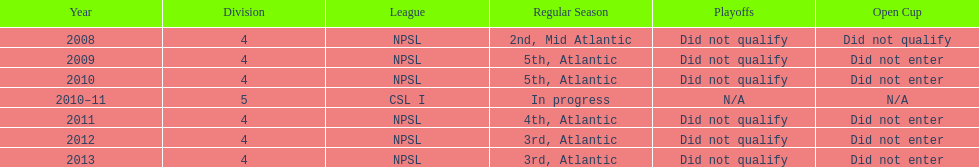For how many years did they fail to qualify for the playoffs? 6. 